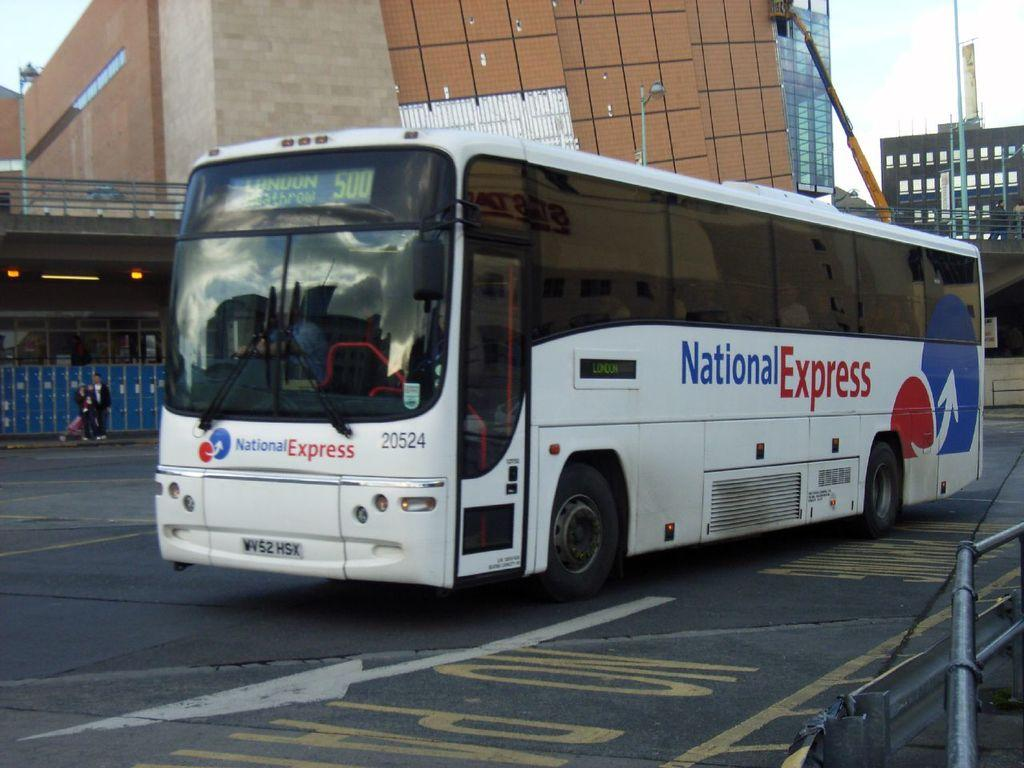What type of vehicle is on the road in the image? There is a bus on the road in the image. What objects can be seen in the image besides the bus? There are rods, people, buildings, lights, and poles visible in the image. What is the background of the image? The sky is visible in the background of the image. Reasoning: Let' Let's think step by step in order to produce the conversation. We start by identifying the main subject in the image, which is the bus on the road. Then, we expand the conversation to include other objects and elements that are also visible, such as rods, people, buildings, lights, and poles. We also mention the background of the image, which is the sky. Each question is designed to elicit a specific detail about the image that is known from the provided facts. Absurd Question/Answer: What type of fan is visible in the image? There is no fan present in the image. What type of hospital can be seen in the image? There is no hospital present in the image. 